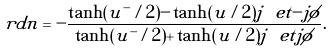<formula> <loc_0><loc_0><loc_500><loc_500>\ r d n = - \frac { \tanh ( u ^ { - } / 2 ) - \tanh ( u / 2 ) j \ e t { - j \phi } } { \tanh ( u ^ { - } / 2 ) + \tanh ( u / 2 ) j \ e t { j \phi } } .</formula> 